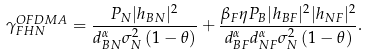<formula> <loc_0><loc_0><loc_500><loc_500>\gamma _ { F H N } ^ { O F D M A } = \frac { P _ { N } { | h _ { B N } | ^ { 2 } } } { { d _ { B N } ^ { \alpha } \sigma _ { N } ^ { 2 } } \left ( 1 - \theta \right ) } + \frac { \beta _ { F } \eta P _ { B } | h _ { B F } | ^ { 2 } | h _ { N F } | ^ { 2 } } { d _ { B F } ^ { \alpha } d _ { N F } ^ { \alpha } \sigma _ { N } ^ { 2 } \left ( 1 - \theta \right ) } .</formula> 